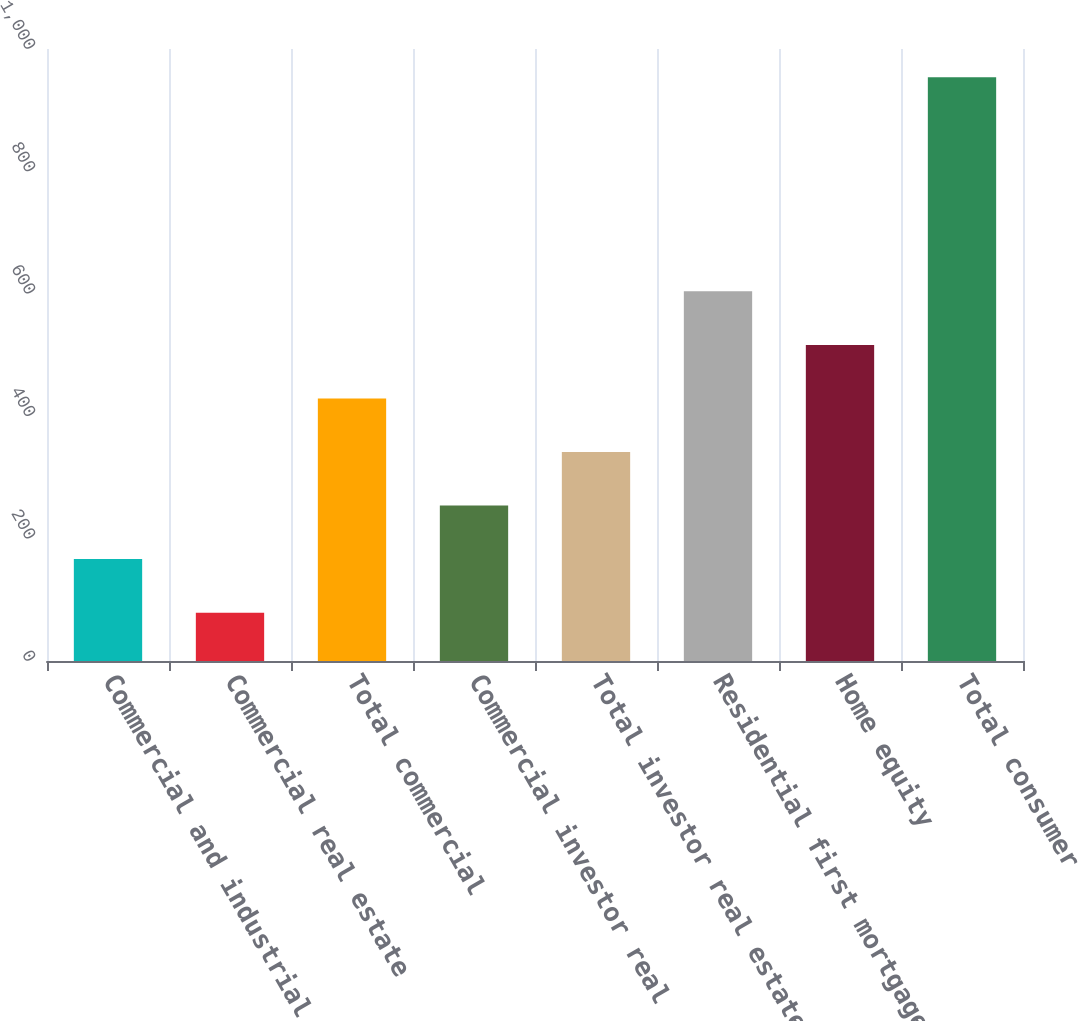Convert chart to OTSL. <chart><loc_0><loc_0><loc_500><loc_500><bar_chart><fcel>Commercial and industrial<fcel>Commercial real estate<fcel>Total commercial<fcel>Commercial investor real<fcel>Total investor real estate<fcel>Residential first mortgage<fcel>Home equity<fcel>Total consumer<nl><fcel>166.5<fcel>79<fcel>429<fcel>254<fcel>341.5<fcel>604<fcel>516.5<fcel>954<nl></chart> 